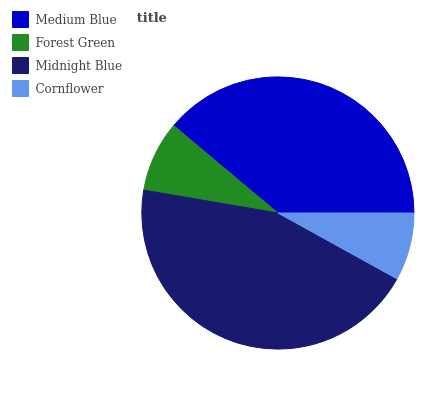Is Cornflower the minimum?
Answer yes or no. Yes. Is Midnight Blue the maximum?
Answer yes or no. Yes. Is Forest Green the minimum?
Answer yes or no. No. Is Forest Green the maximum?
Answer yes or no. No. Is Medium Blue greater than Forest Green?
Answer yes or no. Yes. Is Forest Green less than Medium Blue?
Answer yes or no. Yes. Is Forest Green greater than Medium Blue?
Answer yes or no. No. Is Medium Blue less than Forest Green?
Answer yes or no. No. Is Medium Blue the high median?
Answer yes or no. Yes. Is Forest Green the low median?
Answer yes or no. Yes. Is Midnight Blue the high median?
Answer yes or no. No. Is Midnight Blue the low median?
Answer yes or no. No. 